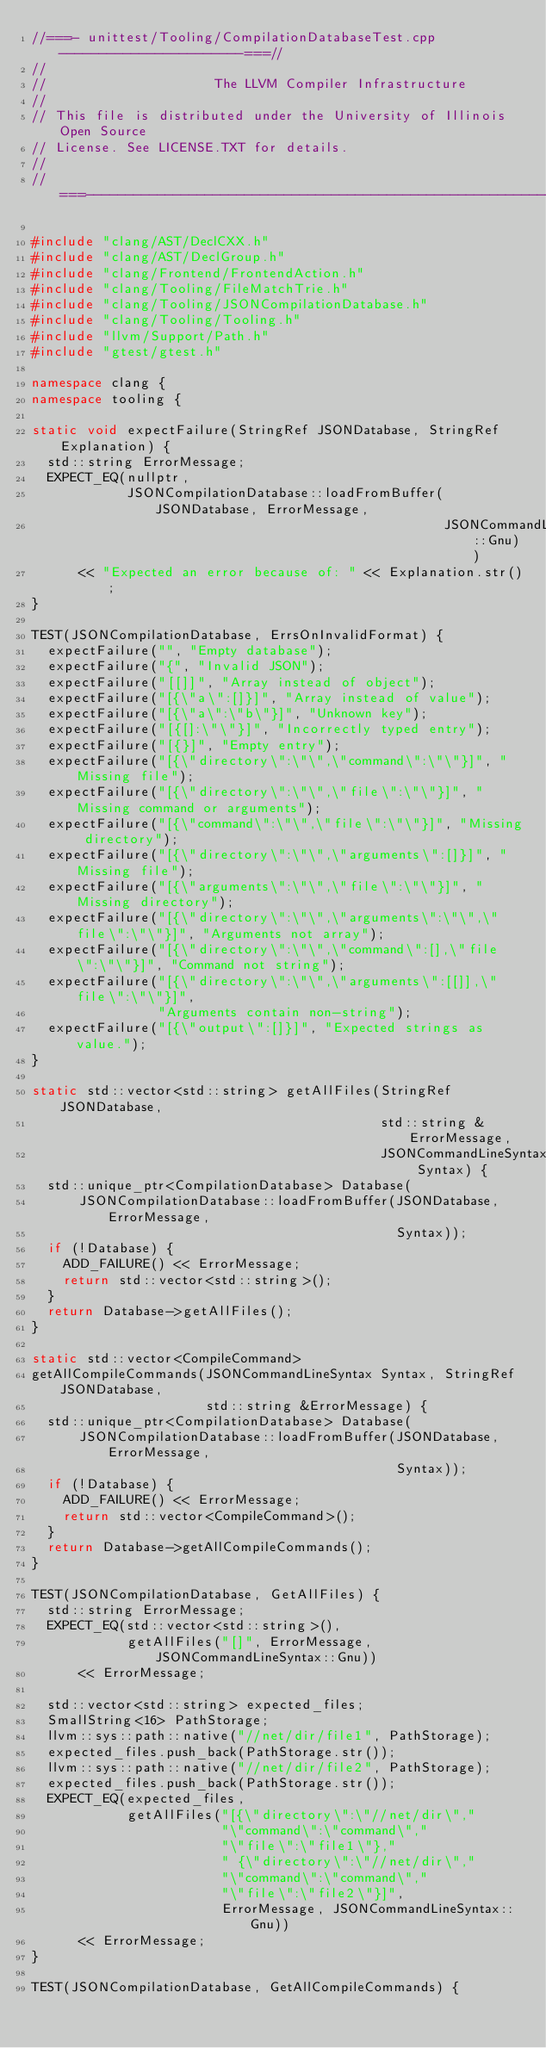Convert code to text. <code><loc_0><loc_0><loc_500><loc_500><_C++_>//===- unittest/Tooling/CompilationDatabaseTest.cpp -----------------------===//
//
//                     The LLVM Compiler Infrastructure
//
// This file is distributed under the University of Illinois Open Source
// License. See LICENSE.TXT for details.
//
//===----------------------------------------------------------------------===//

#include "clang/AST/DeclCXX.h"
#include "clang/AST/DeclGroup.h"
#include "clang/Frontend/FrontendAction.h"
#include "clang/Tooling/FileMatchTrie.h"
#include "clang/Tooling/JSONCompilationDatabase.h"
#include "clang/Tooling/Tooling.h"
#include "llvm/Support/Path.h"
#include "gtest/gtest.h"

namespace clang {
namespace tooling {

static void expectFailure(StringRef JSONDatabase, StringRef Explanation) {
  std::string ErrorMessage;
  EXPECT_EQ(nullptr,
            JSONCompilationDatabase::loadFromBuffer(JSONDatabase, ErrorMessage,
                                                    JSONCommandLineSyntax::Gnu))
      << "Expected an error because of: " << Explanation.str();
}

TEST(JSONCompilationDatabase, ErrsOnInvalidFormat) {
  expectFailure("", "Empty database");
  expectFailure("{", "Invalid JSON");
  expectFailure("[[]]", "Array instead of object");
  expectFailure("[{\"a\":[]}]", "Array instead of value");
  expectFailure("[{\"a\":\"b\"}]", "Unknown key");
  expectFailure("[{[]:\"\"}]", "Incorrectly typed entry");
  expectFailure("[{}]", "Empty entry");
  expectFailure("[{\"directory\":\"\",\"command\":\"\"}]", "Missing file");
  expectFailure("[{\"directory\":\"\",\"file\":\"\"}]", "Missing command or arguments");
  expectFailure("[{\"command\":\"\",\"file\":\"\"}]", "Missing directory");
  expectFailure("[{\"directory\":\"\",\"arguments\":[]}]", "Missing file");
  expectFailure("[{\"arguments\":\"\",\"file\":\"\"}]", "Missing directory");
  expectFailure("[{\"directory\":\"\",\"arguments\":\"\",\"file\":\"\"}]", "Arguments not array");
  expectFailure("[{\"directory\":\"\",\"command\":[],\"file\":\"\"}]", "Command not string");
  expectFailure("[{\"directory\":\"\",\"arguments\":[[]],\"file\":\"\"}]",
                "Arguments contain non-string");
  expectFailure("[{\"output\":[]}]", "Expected strings as value.");
}

static std::vector<std::string> getAllFiles(StringRef JSONDatabase,
                                            std::string &ErrorMessage,
                                            JSONCommandLineSyntax Syntax) {
  std::unique_ptr<CompilationDatabase> Database(
      JSONCompilationDatabase::loadFromBuffer(JSONDatabase, ErrorMessage,
                                              Syntax));
  if (!Database) {
    ADD_FAILURE() << ErrorMessage;
    return std::vector<std::string>();
  }
  return Database->getAllFiles();
}

static std::vector<CompileCommand>
getAllCompileCommands(JSONCommandLineSyntax Syntax, StringRef JSONDatabase,
                      std::string &ErrorMessage) {
  std::unique_ptr<CompilationDatabase> Database(
      JSONCompilationDatabase::loadFromBuffer(JSONDatabase, ErrorMessage,
                                              Syntax));
  if (!Database) {
    ADD_FAILURE() << ErrorMessage;
    return std::vector<CompileCommand>();
  }
  return Database->getAllCompileCommands();
}

TEST(JSONCompilationDatabase, GetAllFiles) {
  std::string ErrorMessage;
  EXPECT_EQ(std::vector<std::string>(),
            getAllFiles("[]", ErrorMessage, JSONCommandLineSyntax::Gnu))
      << ErrorMessage;

  std::vector<std::string> expected_files;
  SmallString<16> PathStorage;
  llvm::sys::path::native("//net/dir/file1", PathStorage);
  expected_files.push_back(PathStorage.str());
  llvm::sys::path::native("//net/dir/file2", PathStorage);
  expected_files.push_back(PathStorage.str());
  EXPECT_EQ(expected_files,
            getAllFiles("[{\"directory\":\"//net/dir\","
                        "\"command\":\"command\","
                        "\"file\":\"file1\"},"
                        " {\"directory\":\"//net/dir\","
                        "\"command\":\"command\","
                        "\"file\":\"file2\"}]",
                        ErrorMessage, JSONCommandLineSyntax::Gnu))
      << ErrorMessage;
}

TEST(JSONCompilationDatabase, GetAllCompileCommands) {</code> 